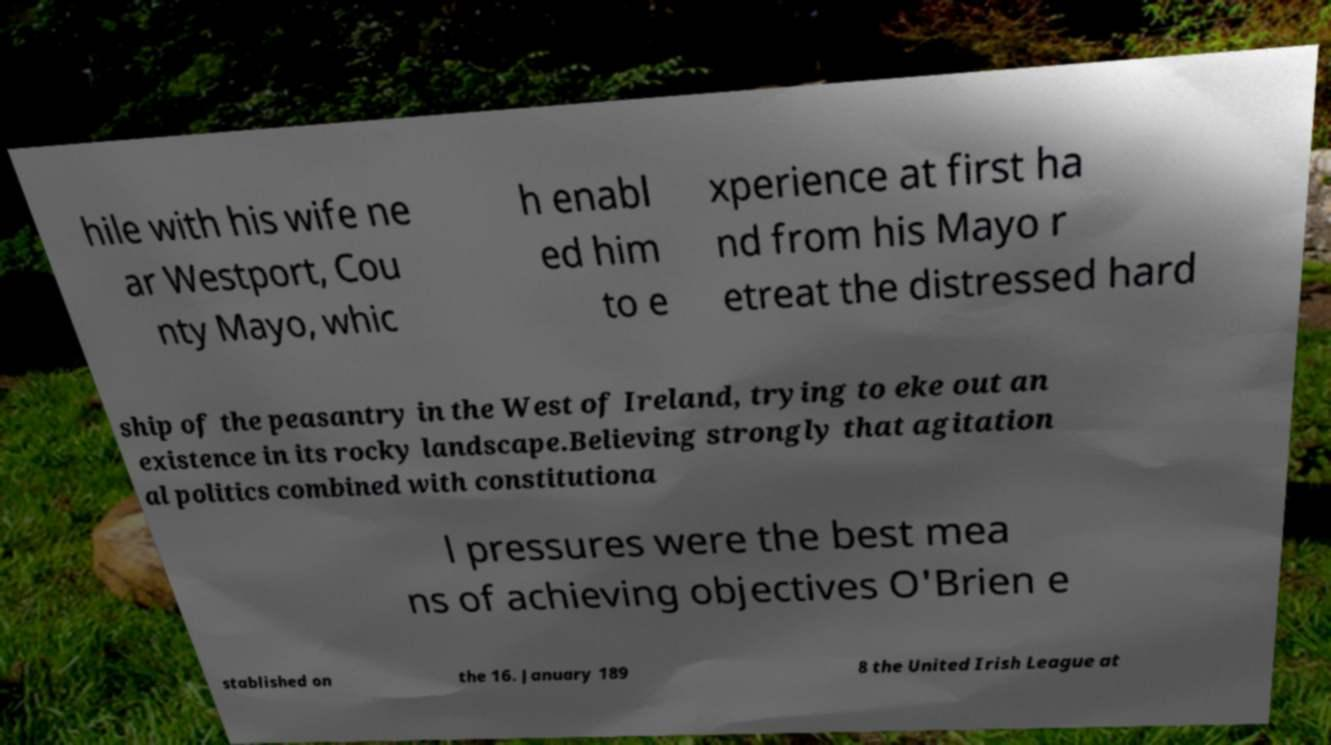There's text embedded in this image that I need extracted. Can you transcribe it verbatim? hile with his wife ne ar Westport, Cou nty Mayo, whic h enabl ed him to e xperience at first ha nd from his Mayo r etreat the distressed hard ship of the peasantry in the West of Ireland, trying to eke out an existence in its rocky landscape.Believing strongly that agitation al politics combined with constitutiona l pressures were the best mea ns of achieving objectives O'Brien e stablished on the 16. January 189 8 the United Irish League at 